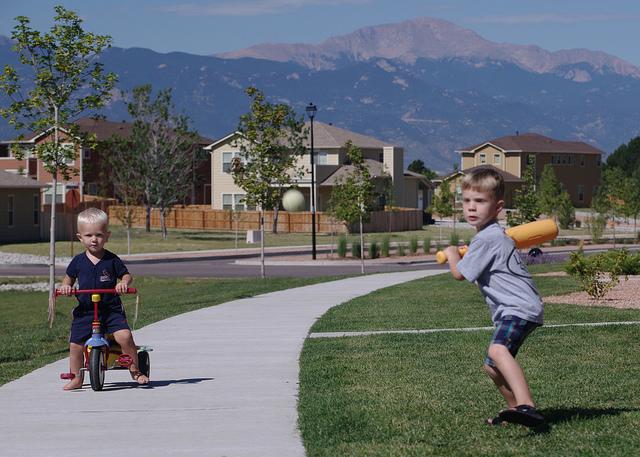Are their shadows behind or in front of them?
Short answer required. Behind. How many kids are in the picture?
Write a very short answer. 2. What are the kids doing?
Concise answer only. Playing. Are these kids promoting healthy habits?
Write a very short answer. Yes. 